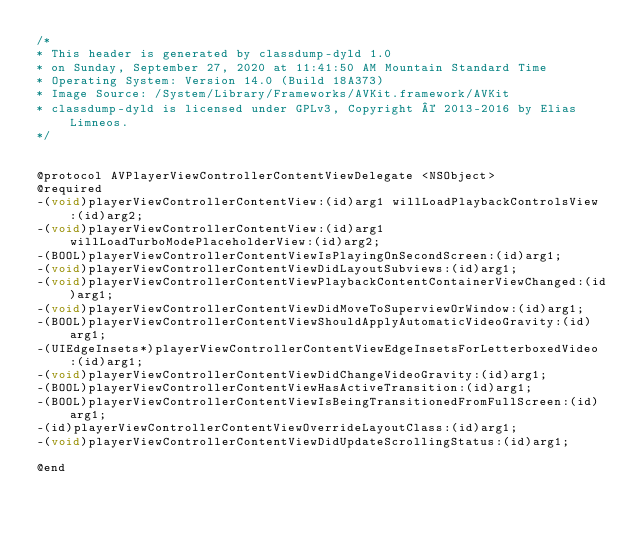Convert code to text. <code><loc_0><loc_0><loc_500><loc_500><_C_>/*
* This header is generated by classdump-dyld 1.0
* on Sunday, September 27, 2020 at 11:41:50 AM Mountain Standard Time
* Operating System: Version 14.0 (Build 18A373)
* Image Source: /System/Library/Frameworks/AVKit.framework/AVKit
* classdump-dyld is licensed under GPLv3, Copyright © 2013-2016 by Elias Limneos.
*/


@protocol AVPlayerViewControllerContentViewDelegate <NSObject>
@required
-(void)playerViewControllerContentView:(id)arg1 willLoadPlaybackControlsView:(id)arg2;
-(void)playerViewControllerContentView:(id)arg1 willLoadTurboModePlaceholderView:(id)arg2;
-(BOOL)playerViewControllerContentViewIsPlayingOnSecondScreen:(id)arg1;
-(void)playerViewControllerContentViewDidLayoutSubviews:(id)arg1;
-(void)playerViewControllerContentViewPlaybackContentContainerViewChanged:(id)arg1;
-(void)playerViewControllerContentViewDidMoveToSuperviewOrWindow:(id)arg1;
-(BOOL)playerViewControllerContentViewShouldApplyAutomaticVideoGravity:(id)arg1;
-(UIEdgeInsets*)playerViewControllerContentViewEdgeInsetsForLetterboxedVideo:(id)arg1;
-(void)playerViewControllerContentViewDidChangeVideoGravity:(id)arg1;
-(BOOL)playerViewControllerContentViewHasActiveTransition:(id)arg1;
-(BOOL)playerViewControllerContentViewIsBeingTransitionedFromFullScreen:(id)arg1;
-(id)playerViewControllerContentViewOverrideLayoutClass:(id)arg1;
-(void)playerViewControllerContentViewDidUpdateScrollingStatus:(id)arg1;

@end

</code> 